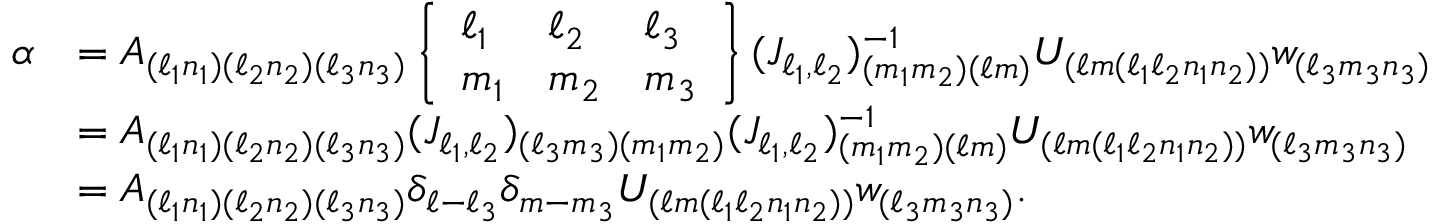Convert formula to latex. <formula><loc_0><loc_0><loc_500><loc_500>\begin{array} { r l } { \alpha } & { = A _ { ( \ell _ { 1 } n _ { 1 } ) ( \ell _ { 2 } n _ { 2 } ) ( \ell _ { 3 } n _ { 3 } ) } \left \{ \begin{array} { l l l } { \ell _ { 1 } } & { \ell _ { 2 } } & { \ell _ { 3 } } \\ { m _ { 1 } } & { m _ { 2 } } & { m _ { 3 } } \end{array} \right \} ( J _ { \ell _ { 1 } , \ell _ { 2 } } ) _ { ( m _ { 1 } m _ { 2 } ) ( \ell m ) } ^ { - 1 } U _ { ( \ell m ( \ell _ { 1 } \ell _ { 2 } n _ { 1 } n _ { 2 } ) ) } w _ { ( \ell _ { 3 } m _ { 3 } n _ { 3 } ) } } \\ & { = A _ { ( \ell _ { 1 } n _ { 1 } ) ( \ell _ { 2 } n _ { 2 } ) ( \ell _ { 3 } n _ { 3 } ) } ( J _ { \ell _ { 1 } , \ell _ { 2 } } ) _ { ( \ell _ { 3 } m _ { 3 } ) ( m _ { 1 } m _ { 2 } ) } ( J _ { \ell _ { 1 } , \ell _ { 2 } } ) _ { ( m _ { 1 } m _ { 2 } ) ( \ell m ) } ^ { - 1 } U _ { ( \ell m ( \ell _ { 1 } \ell _ { 2 } n _ { 1 } n _ { 2 } ) ) } w _ { ( \ell _ { 3 } m _ { 3 } n _ { 3 } ) } } \\ & { = A _ { ( \ell _ { 1 } n _ { 1 } ) ( \ell _ { 2 } n _ { 2 } ) ( \ell _ { 3 } n _ { 3 } ) } \delta _ { \ell - \ell _ { 3 } } \delta _ { m - m _ { 3 } } U _ { ( \ell m ( \ell _ { 1 } \ell _ { 2 } n _ { 1 } n _ { 2 } ) ) } w _ { ( \ell _ { 3 } m _ { 3 } n _ { 3 } ) } . } \end{array}</formula> 